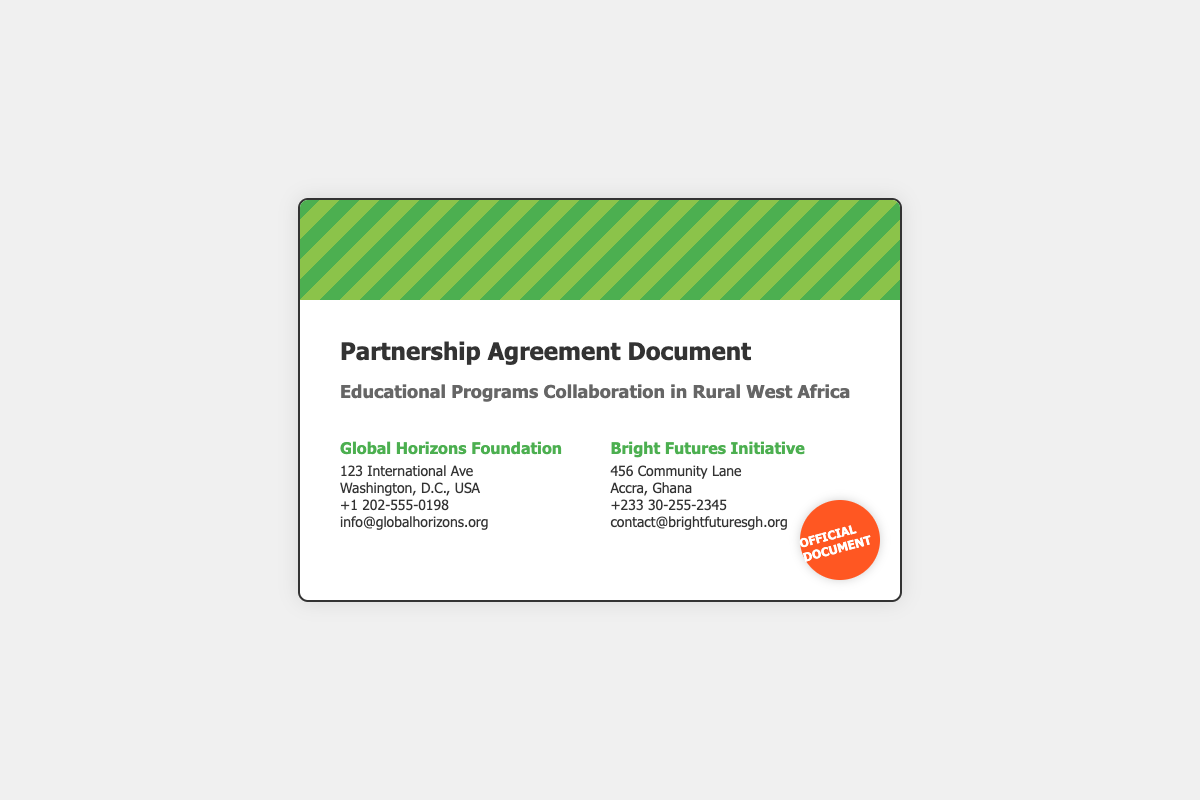What is the title of the document? The title is prominently displayed at the top of the document, indicating the purpose of the document.
Answer: Partnership Agreement Document Who are the two parties involved in the agreement? The agreement lists the parties involved at the top section, providing their names.
Answer: Global Horizons Foundation and Bright Futures Initiative What city is the Bright Futures Initiative located in? The city where the second party's headquarters is located is mentioned in the address details.
Answer: Accra What is the phone number for the Global Horizons Foundation? The phone number for the first party is provided under their contact details.
Answer: +1 202-555-0198 What is the email address for Bright Futures Initiative? The email address for the second party is included in their contact information for communication.
Answer: contact@brightfuturesgh.org What color is the seal in the document? The color of the seal is specifically described as part of its design.
Answer: Orange What is the primary focus of the partnership? The document indicates the main area of collaboration clearly in the subtitle.
Answer: Educational Programs What is the approximate height of the envelope? The dimensions of the envelope are set within the code, indicating its height.
Answer: 400px 